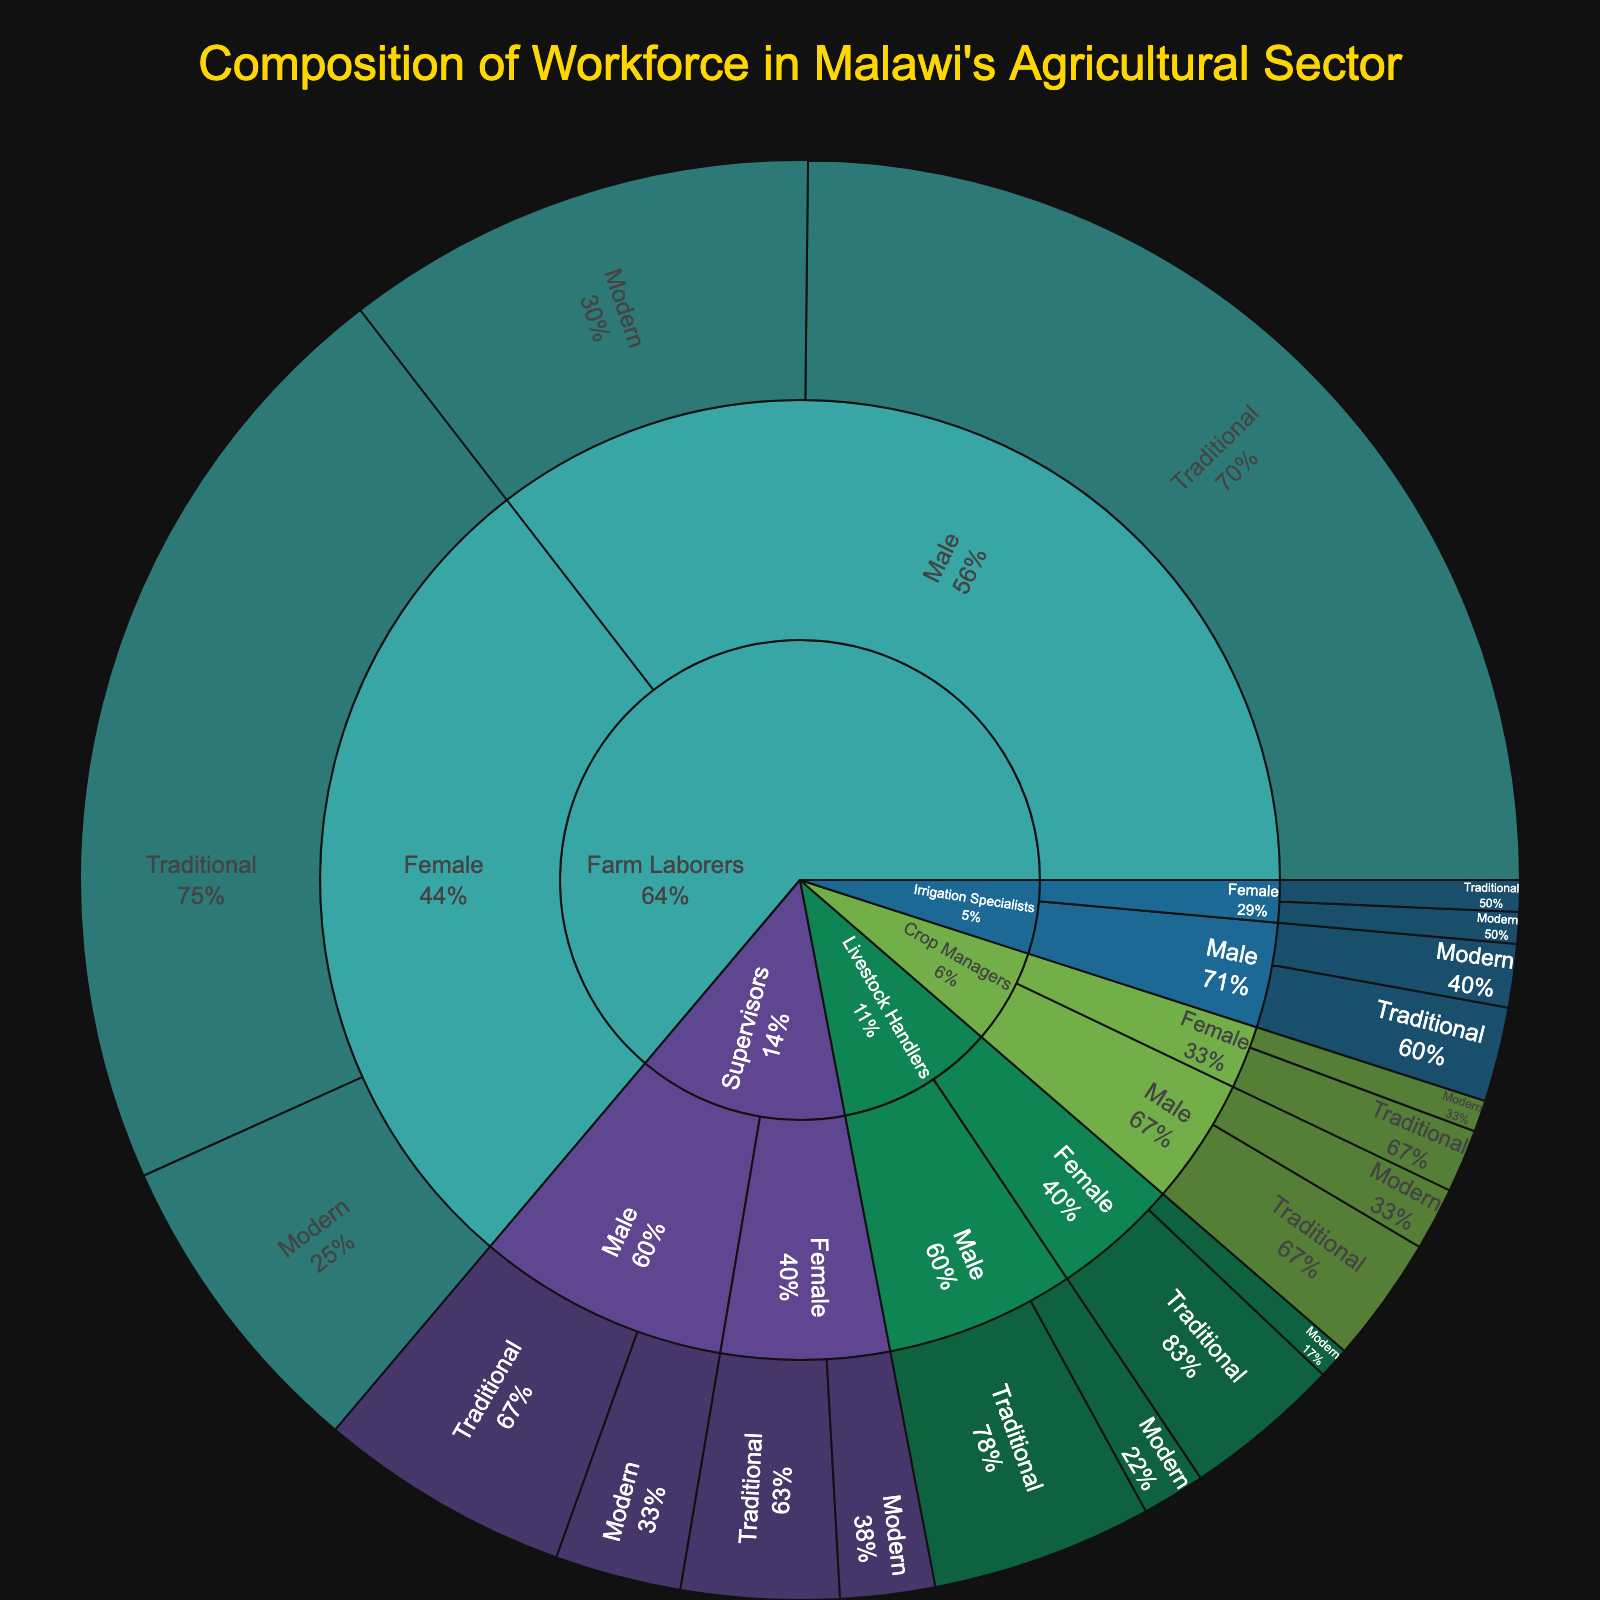What's the title of the figure? The title of the figure is displayed at the top and is meant to give an overview of what the figure is about.
Answer: Composition of Workforce in Malawi's Agricultural Sector Which gender has more farm laborers following traditional farming methods? To answer this, look at the sections for "Farm Laborers" and compare the sizes of the sections for males and females practicing traditional farming.
Answer: Male How many female supervisors use modern farming methods? Look at the section for "Supervisors," then check the female group, and within that, find the segment for modern farming methods. The value is specified in the data.
Answer: 3 What's the total number of male farm laborers? Add the number of male farm laborers using traditional methods to those using modern methods: 35 + 15.
Answer: 50 What percentage of the crop managers are female? The figure displays percentages next to sectors. Add the values for female crop managers and divide by the total number of crop managers, then multiply by 100.
Answer: 3/9 = 33.3% Which role has the least number of people, and what is that number? Compare all the roles and find the one with the smallest total combined value (sum of male and female in both traditional and modern methods).
Answer: Irrigation Specialists, 7 Do more male or female livestock handlers follow modern farming methods? Compare the sections for "Livestock Handlers" and see the values for modern farming under both genders.
Answer: Male What's the difference in the number of male and female workers in traditional farming methods across all roles? Sum up all male workers in traditional farming methods for all roles, then sum up all female workers, and subtract the smaller sum from the larger sum: (35 + 8 + 3 + 7 + 4) - (30 + 5 + 1 + 5 + 2).
Answer: 62 - 43 = 19 